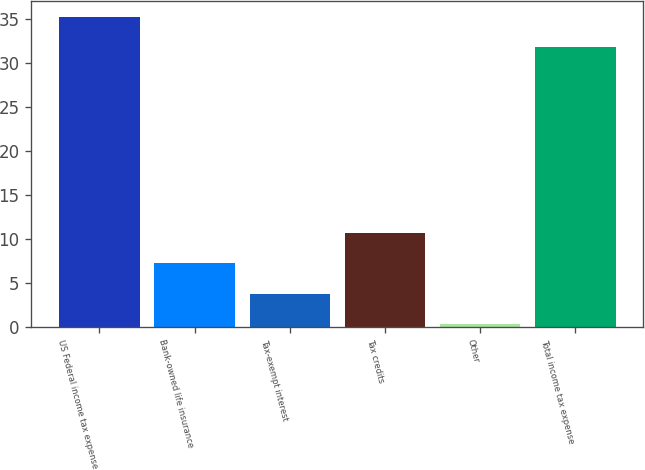<chart> <loc_0><loc_0><loc_500><loc_500><bar_chart><fcel>US Federal income tax expense<fcel>Bank-owned life insurance<fcel>Tax-exempt interest<fcel>Tax credits<fcel>Other<fcel>Total income tax expense<nl><fcel>35.27<fcel>7.24<fcel>3.77<fcel>10.71<fcel>0.3<fcel>31.8<nl></chart> 